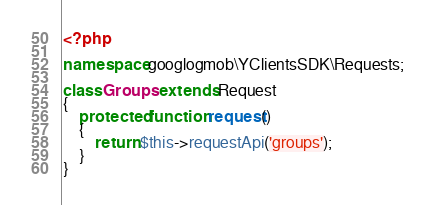Convert code to text. <code><loc_0><loc_0><loc_500><loc_500><_PHP_><?php

namespace googlogmob\YClientsSDK\Requests;

class Groups extends Request
{
    protected function request()
    {
        return $this->requestApi('groups');
    }
}
</code> 